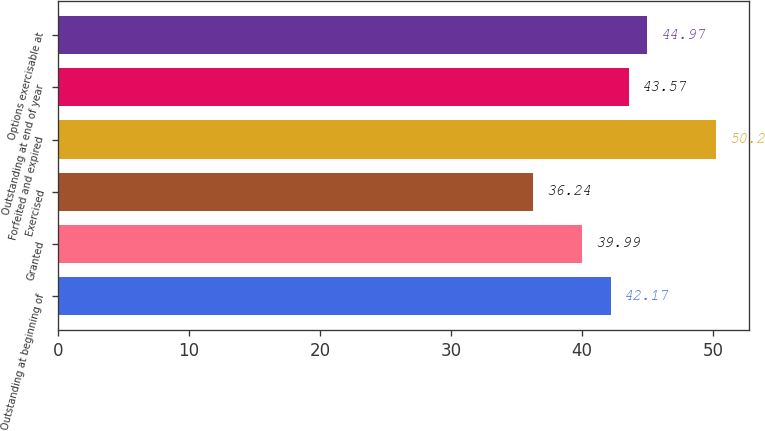Convert chart. <chart><loc_0><loc_0><loc_500><loc_500><bar_chart><fcel>Outstanding at beginning of<fcel>Granted<fcel>Exercised<fcel>Forfeited and expired<fcel>Outstanding at end of year<fcel>Options exercisable at<nl><fcel>42.17<fcel>39.99<fcel>36.24<fcel>50.2<fcel>43.57<fcel>44.97<nl></chart> 